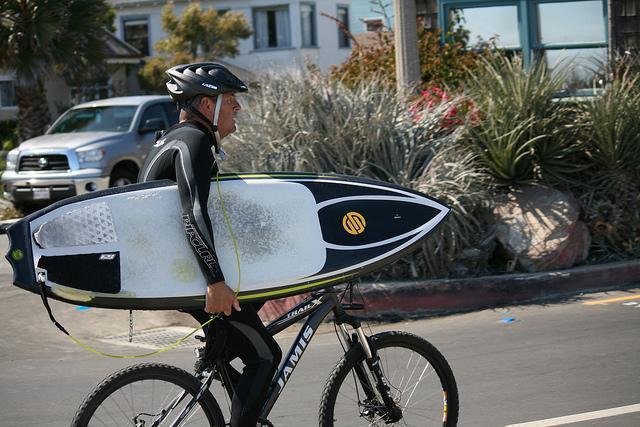How many people are there?
Give a very brief answer. 1. How many boats are parked next to the red truck?
Give a very brief answer. 0. 